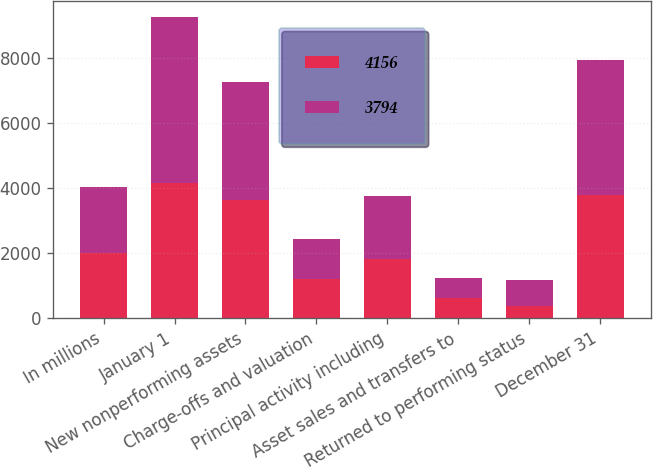Convert chart. <chart><loc_0><loc_0><loc_500><loc_500><stacked_bar_chart><ecel><fcel>In millions<fcel>January 1<fcel>New nonperforming assets<fcel>Charge-offs and valuation<fcel>Principal activity including<fcel>Asset sales and transfers to<fcel>Returned to performing status<fcel>December 31<nl><fcel>4156<fcel>2012<fcel>4156<fcel>3648<fcel>1218<fcel>1812<fcel>610<fcel>370<fcel>3794<nl><fcel>3794<fcel>2011<fcel>5123<fcel>3625<fcel>1220<fcel>1960<fcel>613<fcel>799<fcel>4156<nl></chart> 